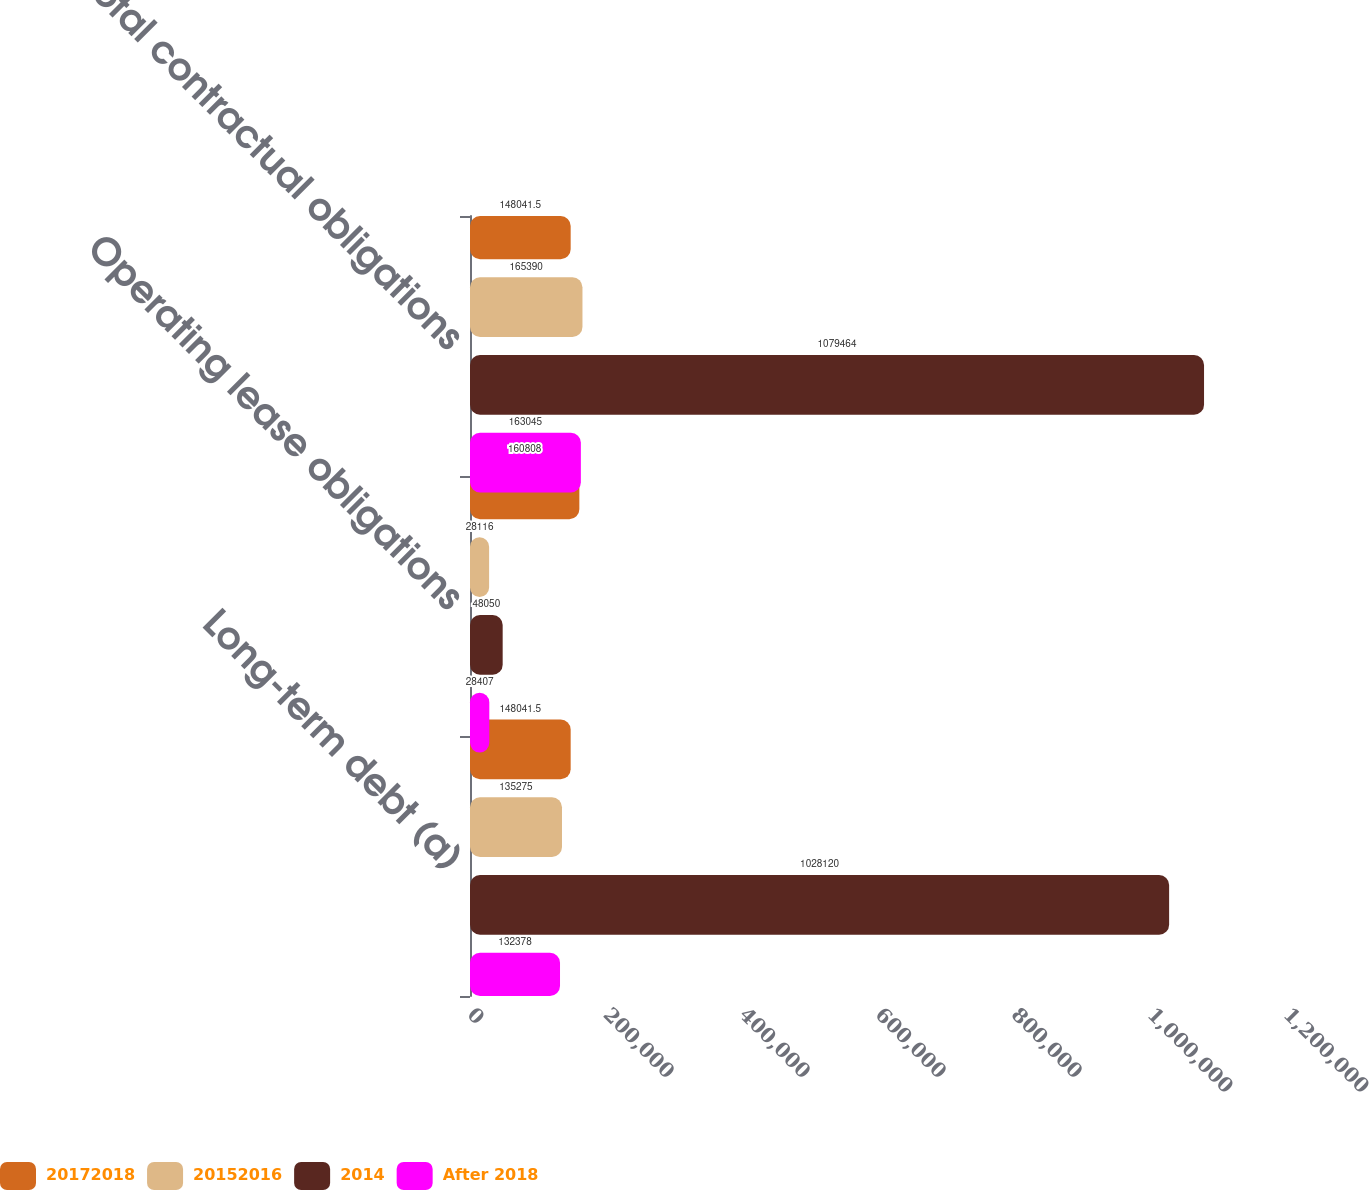<chart> <loc_0><loc_0><loc_500><loc_500><stacked_bar_chart><ecel><fcel>Long-term debt (a)<fcel>Operating lease obligations<fcel>Total contractual obligations<nl><fcel>20172018<fcel>148042<fcel>160808<fcel>148042<nl><fcel>20152016<fcel>135275<fcel>28116<fcel>165390<nl><fcel>2014<fcel>1.02812e+06<fcel>48050<fcel>1.07946e+06<nl><fcel>After 2018<fcel>132378<fcel>28407<fcel>163045<nl></chart> 